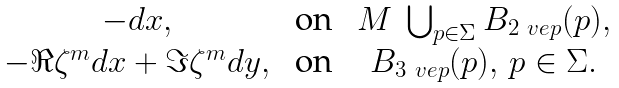<formula> <loc_0><loc_0><loc_500><loc_500>\begin{matrix} - d x , & \text { on } & M \ \bigcup _ { p \in \Sigma } B _ { 2 \ v e p } ( p ) , \\ - \Re { \zeta } ^ { m } d x + \Im { \zeta } ^ { m } d y , & \text { on } & B _ { 3 \ v e p } ( p ) , \, p \in \Sigma . \end{matrix}</formula> 